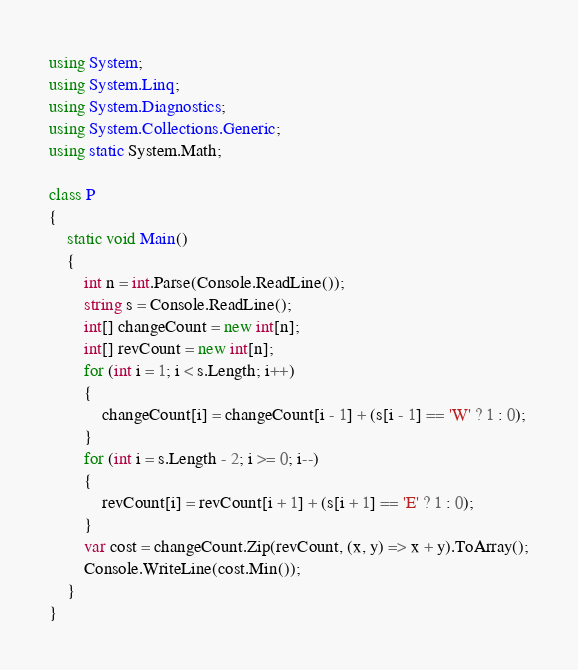Convert code to text. <code><loc_0><loc_0><loc_500><loc_500><_C#_>using System;
using System.Linq;
using System.Diagnostics;
using System.Collections.Generic;
using static System.Math;

class P
{
    static void Main()
    {
        int n = int.Parse(Console.ReadLine());
        string s = Console.ReadLine();
        int[] changeCount = new int[n];
        int[] revCount = new int[n];
        for (int i = 1; i < s.Length; i++)
        {
            changeCount[i] = changeCount[i - 1] + (s[i - 1] == 'W' ? 1 : 0);
        }
        for (int i = s.Length - 2; i >= 0; i--)
        {
            revCount[i] = revCount[i + 1] + (s[i + 1] == 'E' ? 1 : 0);
        }
        var cost = changeCount.Zip(revCount, (x, y) => x + y).ToArray();
        Console.WriteLine(cost.Min());
    }
}</code> 